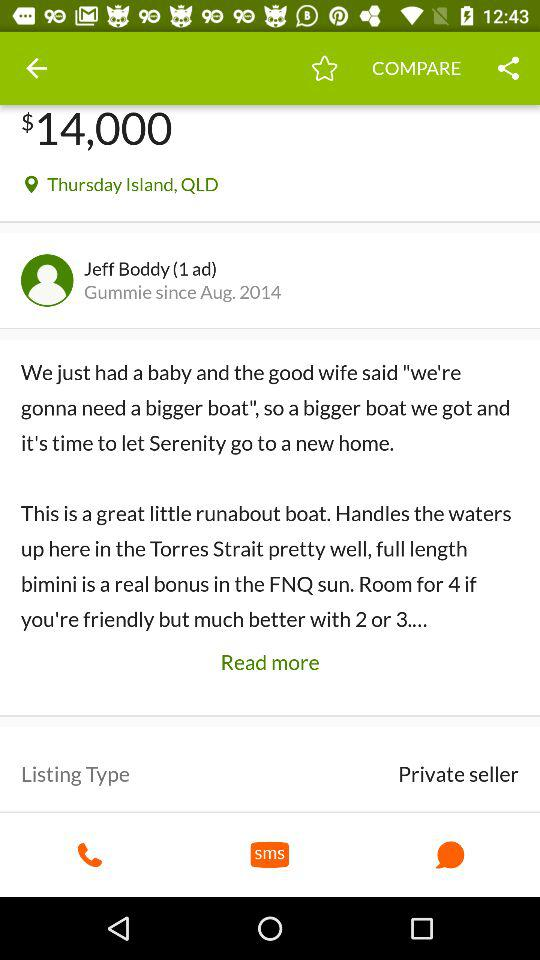What's the price? The price is $14,000. 